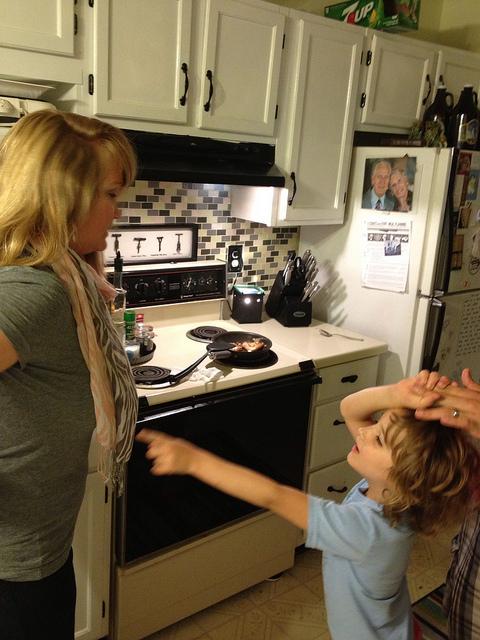Where is the kid pointing?
Write a very short answer. Mom. How many people are in the picture on side of refrigerator?
Quick response, please. 2. How is the ladies hair fixed?
Be succinct. Straight. Is something being cooked on the stove?
Write a very short answer. Yes. 